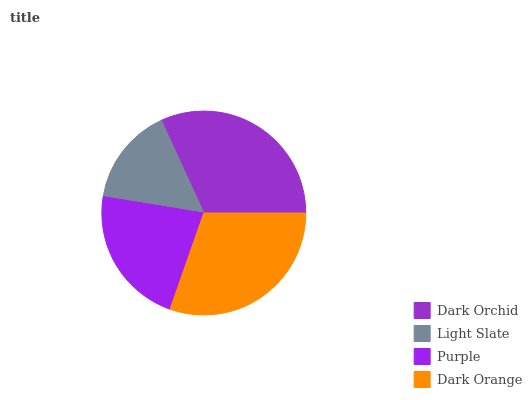Is Light Slate the minimum?
Answer yes or no. Yes. Is Dark Orchid the maximum?
Answer yes or no. Yes. Is Purple the minimum?
Answer yes or no. No. Is Purple the maximum?
Answer yes or no. No. Is Purple greater than Light Slate?
Answer yes or no. Yes. Is Light Slate less than Purple?
Answer yes or no. Yes. Is Light Slate greater than Purple?
Answer yes or no. No. Is Purple less than Light Slate?
Answer yes or no. No. Is Dark Orange the high median?
Answer yes or no. Yes. Is Purple the low median?
Answer yes or no. Yes. Is Purple the high median?
Answer yes or no. No. Is Dark Orange the low median?
Answer yes or no. No. 